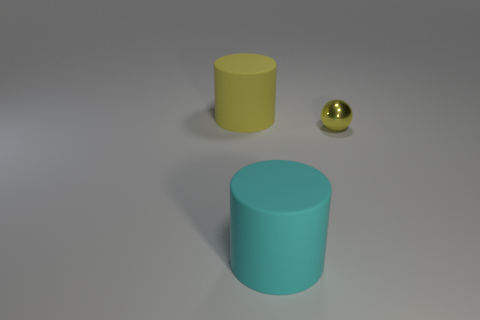Is there any other thing that has the same material as the small yellow ball?
Offer a very short reply. No. Does the cylinder in front of the tiny ball have the same material as the large yellow thing?
Provide a succinct answer. Yes. Is the number of cylinders that are left of the cyan rubber cylinder the same as the number of cyan cylinders behind the tiny object?
Provide a succinct answer. No. There is a big thing that is the same color as the metallic sphere; what material is it?
Your response must be concise. Rubber. There is a large object that is on the left side of the cyan thing; how many yellow objects are in front of it?
Offer a very short reply. 1. There is a small metallic sphere that is in front of the big yellow cylinder; is its color the same as the large matte thing behind the cyan rubber thing?
Ensure brevity in your answer.  Yes. The matte thing that is behind the large matte thing that is in front of the yellow object that is left of the shiny sphere is what shape?
Keep it short and to the point. Cylinder. There is a object that is the same size as the cyan matte cylinder; what shape is it?
Offer a terse response. Cylinder. There is a big rubber cylinder that is to the left of the large cylinder in front of the large yellow cylinder; how many small shiny spheres are in front of it?
Give a very brief answer. 1. Is the number of tiny yellow metal spheres that are to the right of the tiny yellow shiny sphere greater than the number of small yellow spheres behind the large yellow matte object?
Keep it short and to the point. No. 